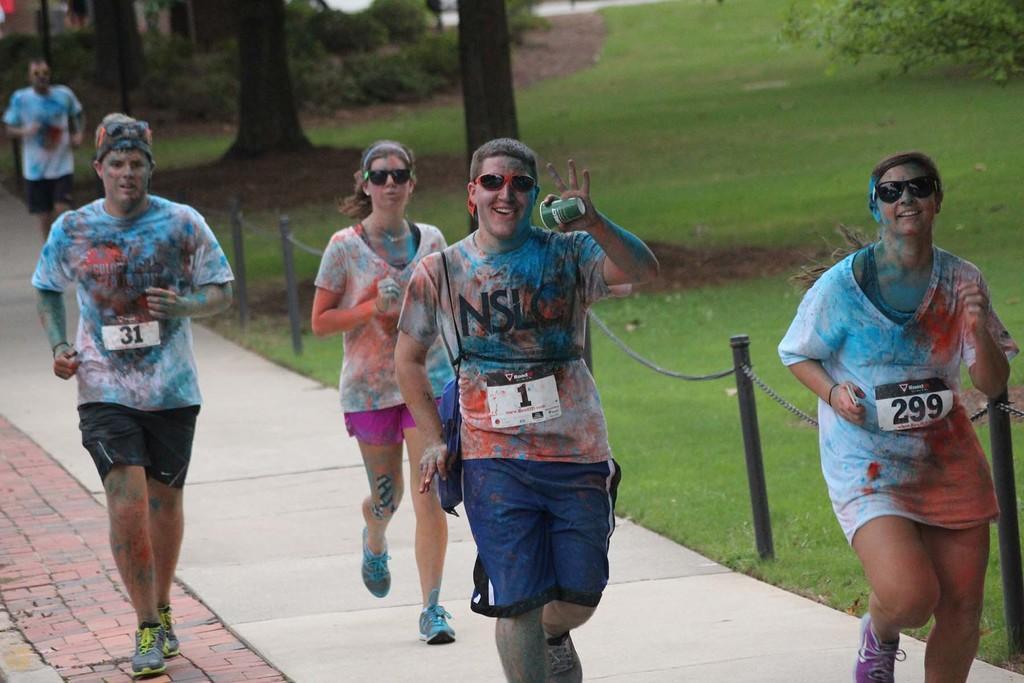Please provide a concise description of this image. In this picture we can see a group of people running on the ground, fence, grass and in the background we can see trees. 